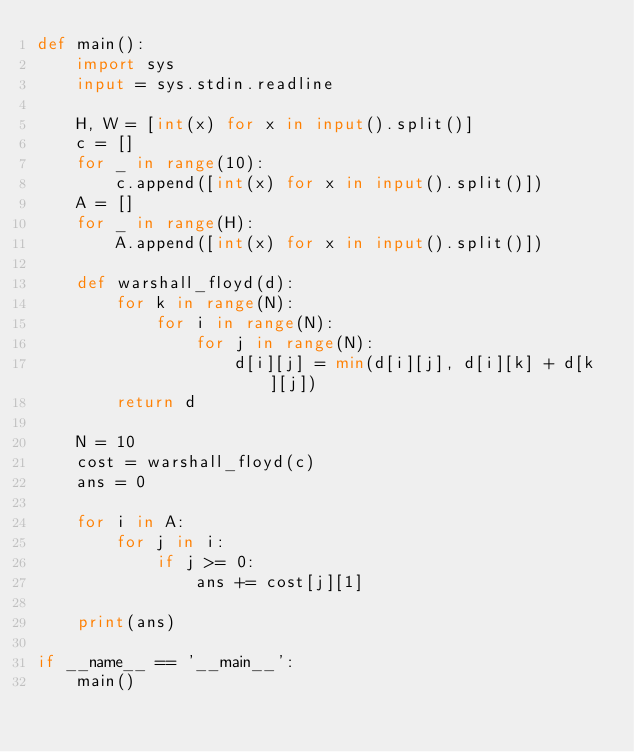Convert code to text. <code><loc_0><loc_0><loc_500><loc_500><_Python_>def main():
    import sys
    input = sys.stdin.readline
    
    H, W = [int(x) for x in input().split()]
    c = []
    for _ in range(10):
        c.append([int(x) for x in input().split()])
    A = []
    for _ in range(H):
        A.append([int(x) for x in input().split()])

    def warshall_floyd(d):
        for k in range(N):
            for i in range(N):
                for j in range(N):
                    d[i][j] = min(d[i][j], d[i][k] + d[k][j])
        return d

    N = 10
    cost = warshall_floyd(c)
    ans = 0

    for i in A:
        for j in i:
            if j >= 0:
                ans += cost[j][1]

    print(ans)

if __name__ == '__main__':
    main()
</code> 